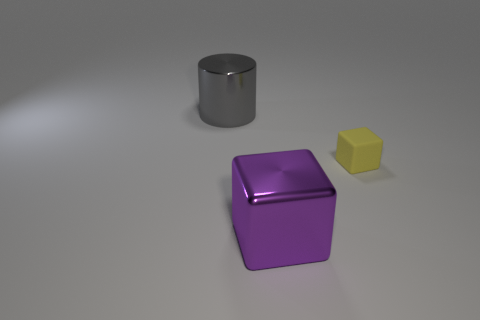Add 3 brown matte spheres. How many objects exist? 6 Subtract all blocks. How many objects are left? 1 Add 2 green cylinders. How many green cylinders exist? 2 Subtract 0 red cylinders. How many objects are left? 3 Subtract all red matte blocks. Subtract all large blocks. How many objects are left? 2 Add 3 purple metallic blocks. How many purple metallic blocks are left? 4 